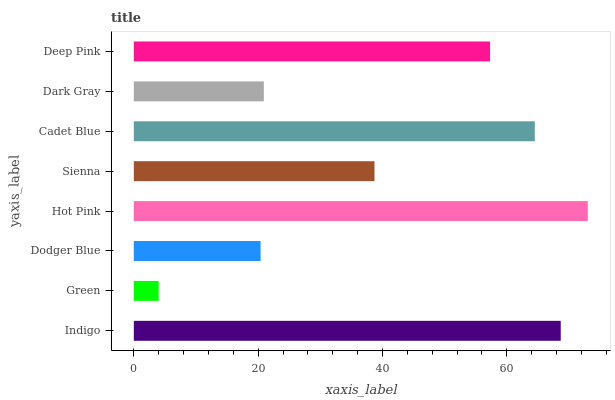Is Green the minimum?
Answer yes or no. Yes. Is Hot Pink the maximum?
Answer yes or no. Yes. Is Dodger Blue the minimum?
Answer yes or no. No. Is Dodger Blue the maximum?
Answer yes or no. No. Is Dodger Blue greater than Green?
Answer yes or no. Yes. Is Green less than Dodger Blue?
Answer yes or no. Yes. Is Green greater than Dodger Blue?
Answer yes or no. No. Is Dodger Blue less than Green?
Answer yes or no. No. Is Deep Pink the high median?
Answer yes or no. Yes. Is Sienna the low median?
Answer yes or no. Yes. Is Dark Gray the high median?
Answer yes or no. No. Is Hot Pink the low median?
Answer yes or no. No. 